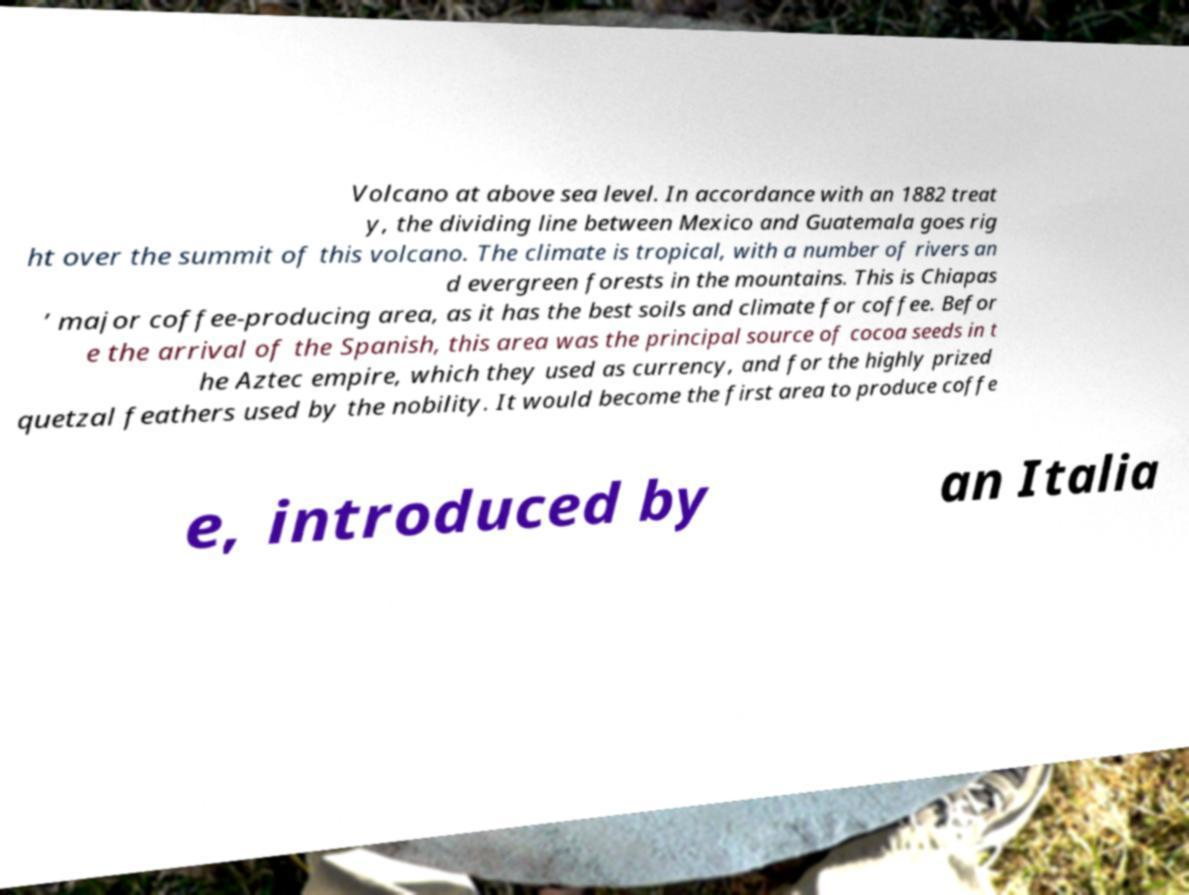What messages or text are displayed in this image? I need them in a readable, typed format. Volcano at above sea level. In accordance with an 1882 treat y, the dividing line between Mexico and Guatemala goes rig ht over the summit of this volcano. The climate is tropical, with a number of rivers an d evergreen forests in the mountains. This is Chiapas ’ major coffee-producing area, as it has the best soils and climate for coffee. Befor e the arrival of the Spanish, this area was the principal source of cocoa seeds in t he Aztec empire, which they used as currency, and for the highly prized quetzal feathers used by the nobility. It would become the first area to produce coffe e, introduced by an Italia 